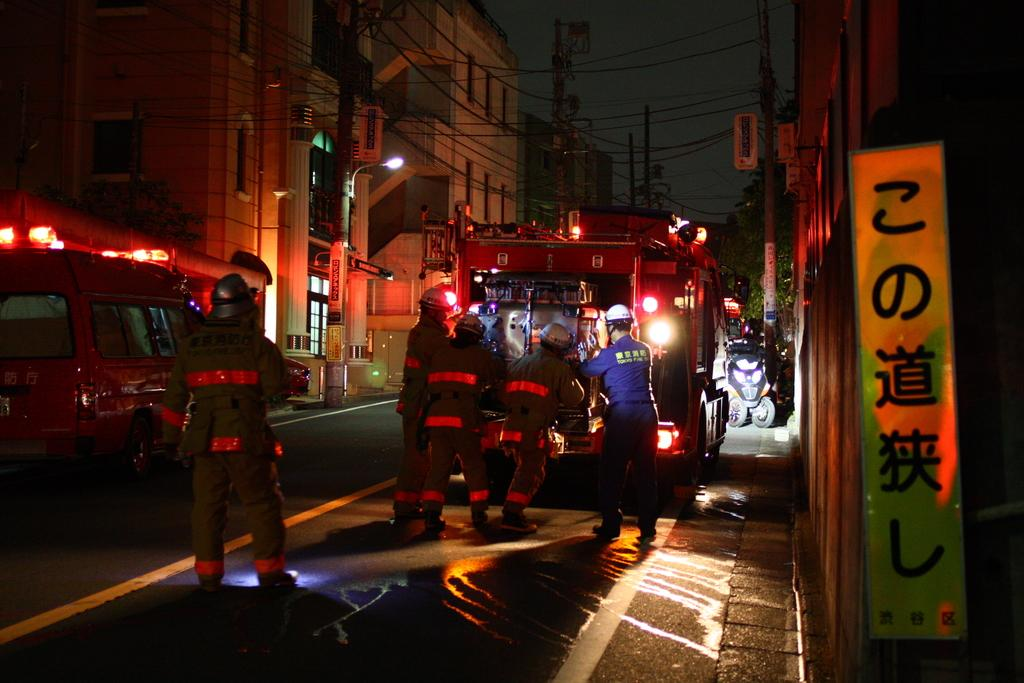Who or what can be seen in the image? There are people in the image. What else is visible on the road in the image? There are vehicles on the road in the image. What structures are present in the image? There are buildings in the image. What are the power poles used for in the image? Power poles are present in the image. What type of vegetation is visible in the image? There are trees in the image. What part of the natural environment is visible in the image? The sky is visible in the image. What type of nose can be seen on the animal in the image? There is no animal present in the image, and therefore no nose can be observed. What is the animal using to support itself in the image? There is no animal present in the image, and therefore no support is needed. 